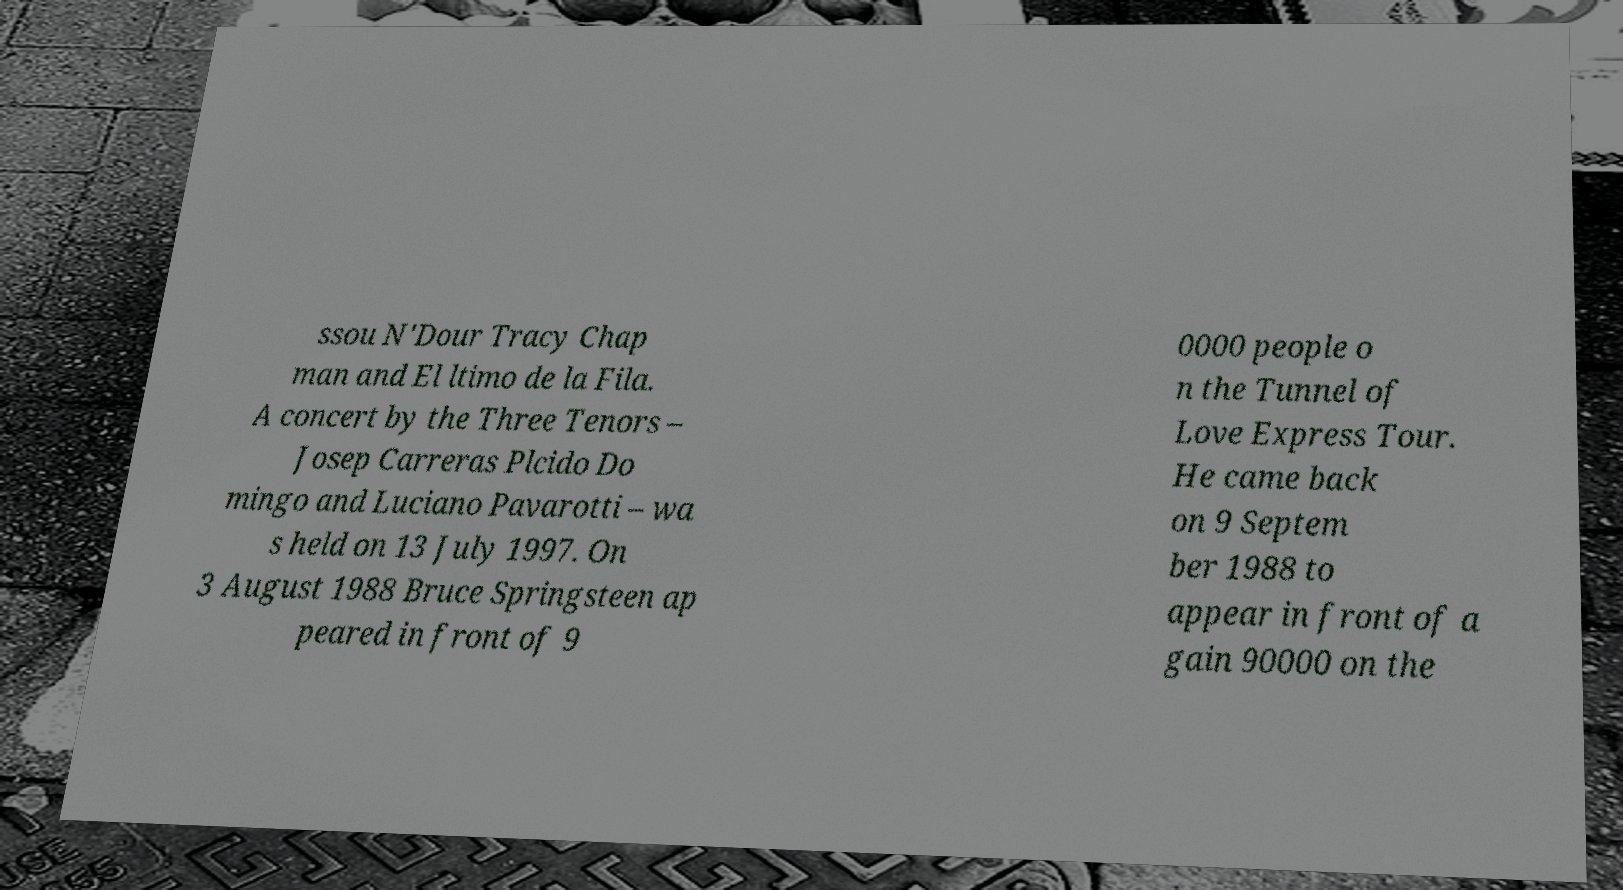There's text embedded in this image that I need extracted. Can you transcribe it verbatim? ssou N'Dour Tracy Chap man and El ltimo de la Fila. A concert by the Three Tenors – Josep Carreras Plcido Do mingo and Luciano Pavarotti – wa s held on 13 July 1997. On 3 August 1988 Bruce Springsteen ap peared in front of 9 0000 people o n the Tunnel of Love Express Tour. He came back on 9 Septem ber 1988 to appear in front of a gain 90000 on the 